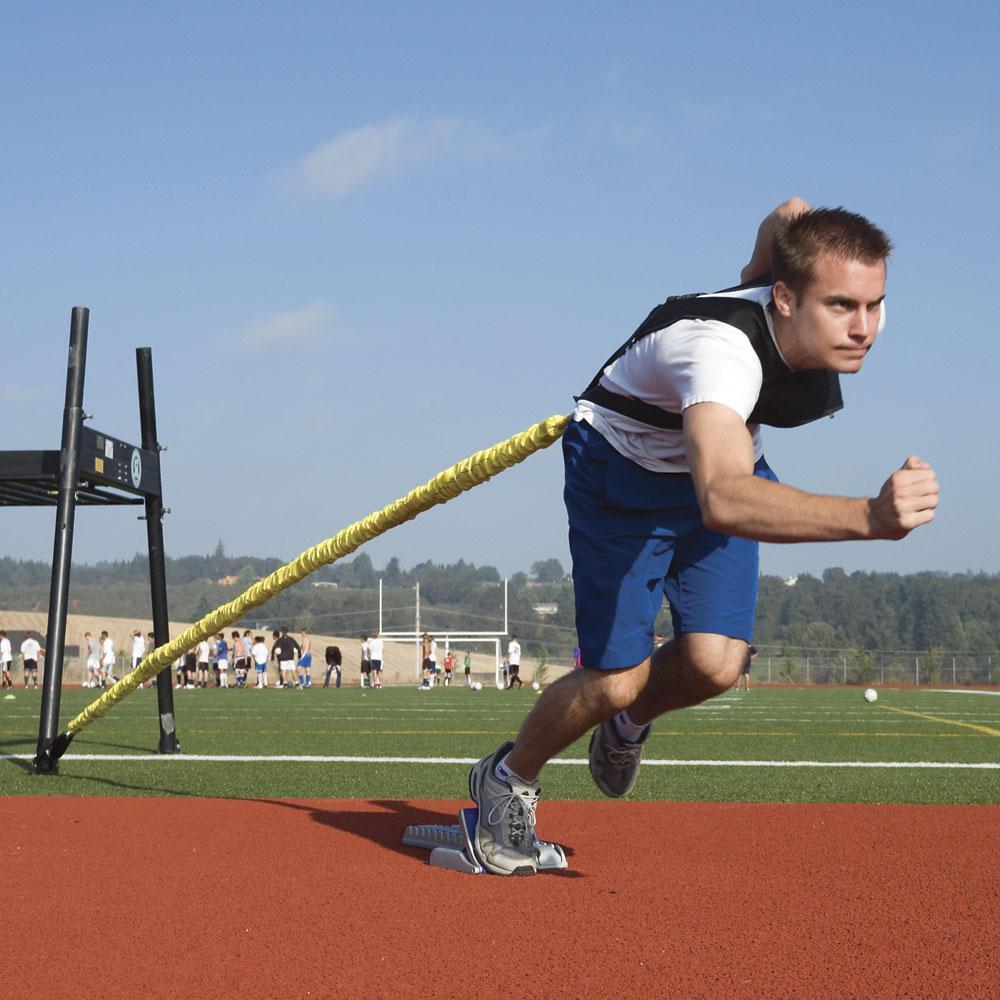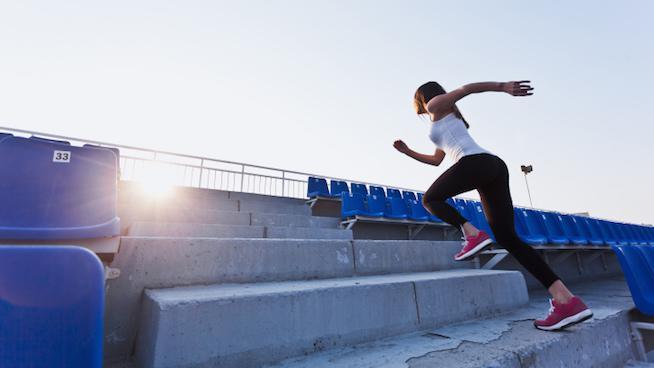The first image is the image on the left, the second image is the image on the right. Examine the images to the left and right. Is the description "One of the runners is running on a road and the other is running by a body of water." accurate? Answer yes or no. No. The first image is the image on the left, the second image is the image on the right. Evaluate the accuracy of this statement regarding the images: "One person is running leftward in front of a body of water.". Is it true? Answer yes or no. No. 